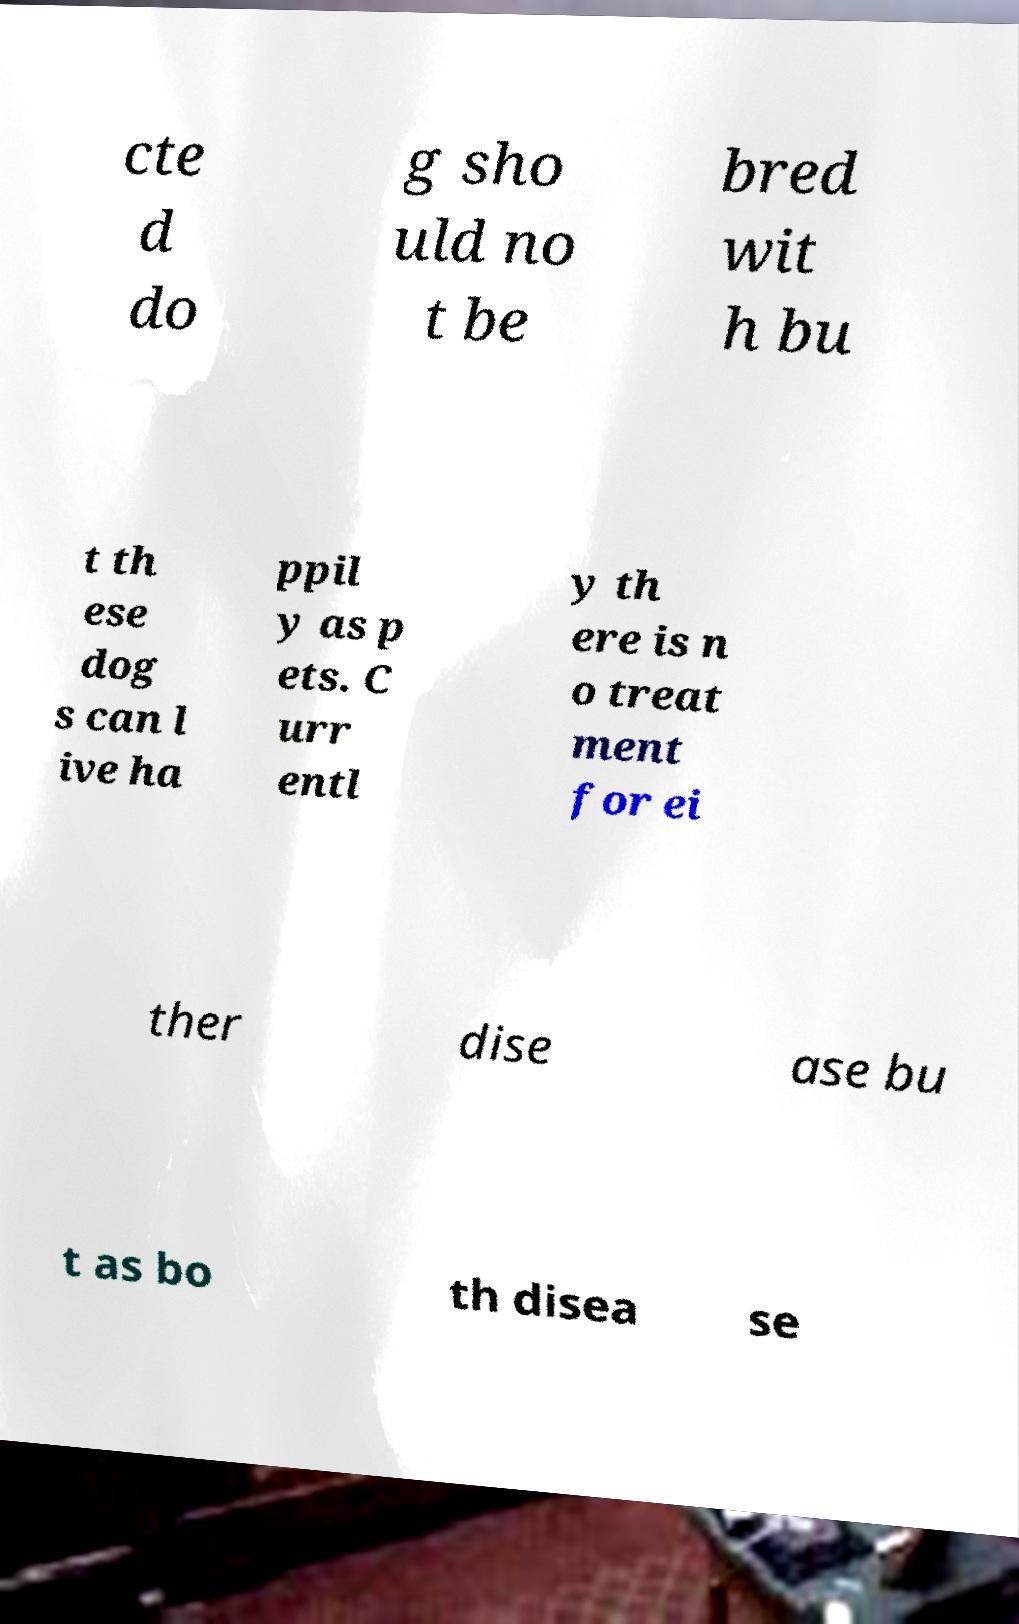Can you read and provide the text displayed in the image?This photo seems to have some interesting text. Can you extract and type it out for me? cte d do g sho uld no t be bred wit h bu t th ese dog s can l ive ha ppil y as p ets. C urr entl y th ere is n o treat ment for ei ther dise ase bu t as bo th disea se 